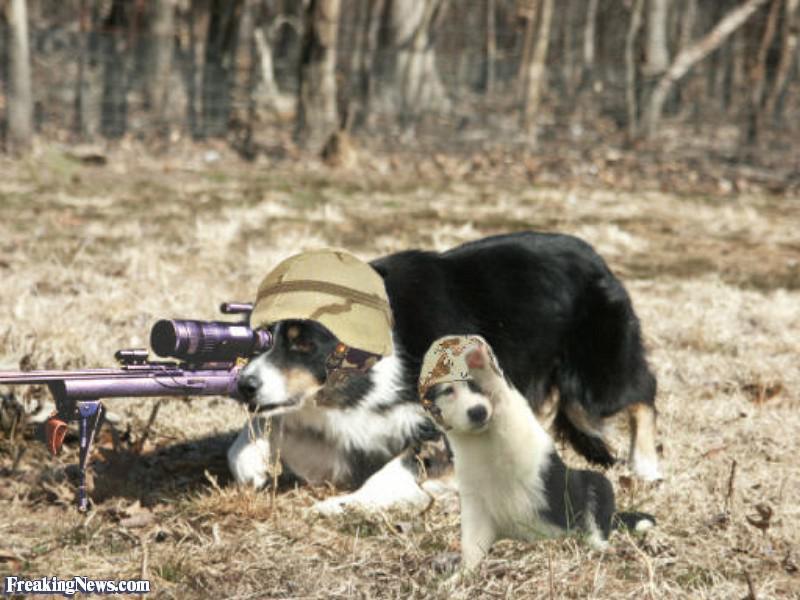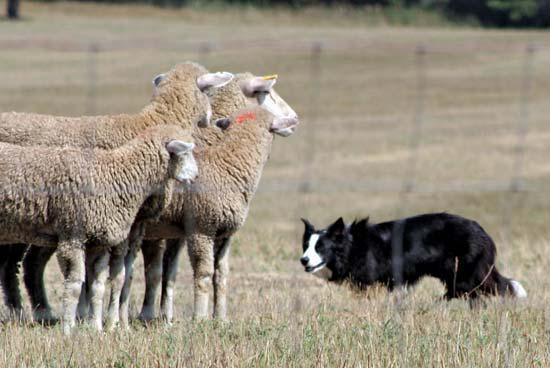The first image is the image on the left, the second image is the image on the right. For the images shown, is this caption "One of the images shows exactly two dogs." true? Answer yes or no. Yes. 